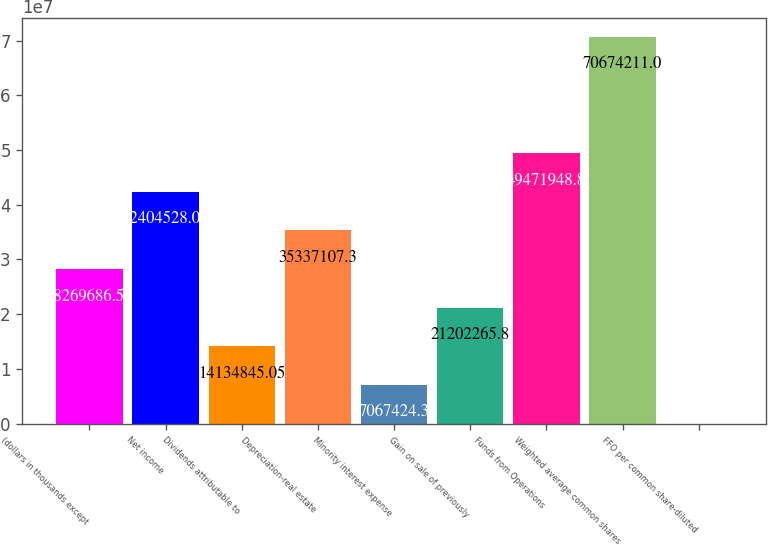<chart> <loc_0><loc_0><loc_500><loc_500><bar_chart><fcel>(dollars in thousands except<fcel>Net income<fcel>Dividends attributable to<fcel>Depreciation-real estate<fcel>Minority interest expense<fcel>Gain on sale of previously<fcel>Funds from Operations<fcel>Weighted average common shares<fcel>FFO per common share-diluted<nl><fcel>2.82697e+07<fcel>4.24045e+07<fcel>1.41348e+07<fcel>3.53371e+07<fcel>7.06742e+06<fcel>2.12023e+07<fcel>4.94719e+07<fcel>7.06742e+07<fcel>3.55<nl></chart> 